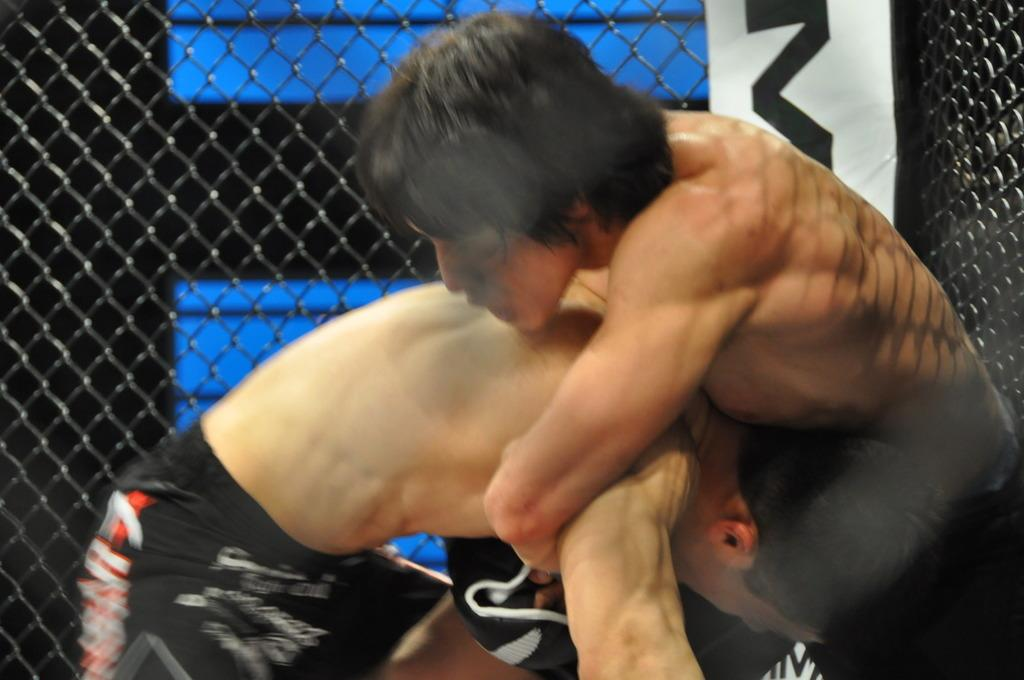How many people are in the image? There are two men in the image. What are the men doing in the image? The men are holding each other. What can be seen on the wall in the background of the image? There is a poster and a mesh visible on the wall. What type of face can be seen on the pin in the image? There is no pin or face present in the image. What color is the spot on the wall in the image? There is no spot visible on the wall in the image. 